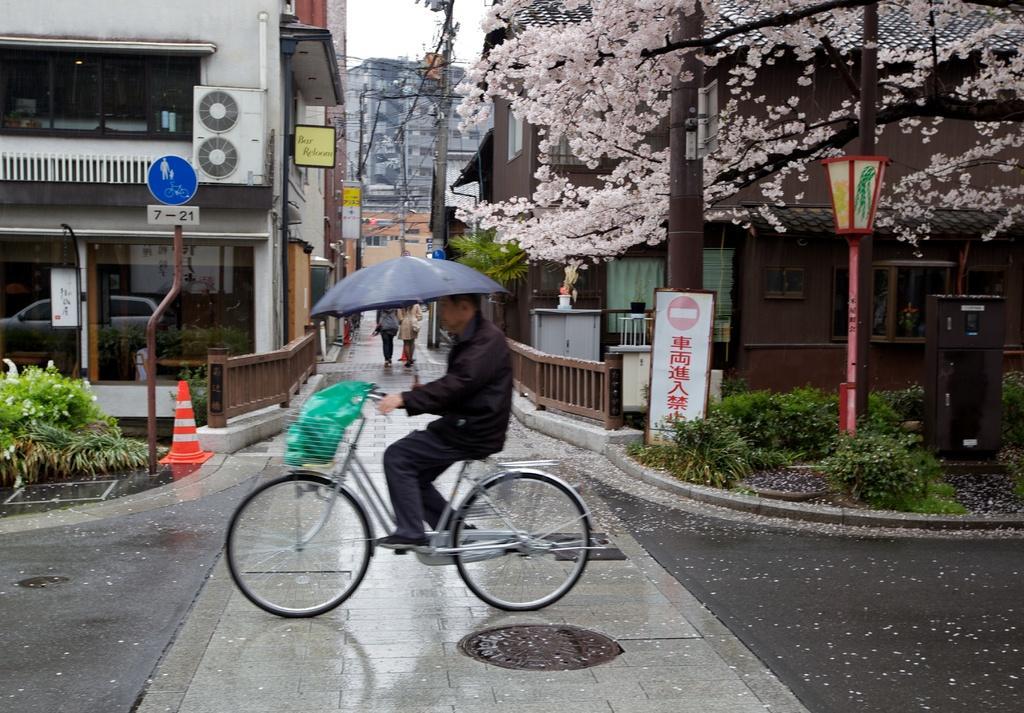In one or two sentences, can you explain what this image depicts? In the image we can see there is a man who is sitting on bicycle and there is a green colour cover in the basket of a bicycle. Beside there are buildings, there are trees and plants in the area. There is traffic cone which is kept in the corner of the road and there are people who are standing on the road. The man is holding umbrella, at the back there is an electric light pole. 